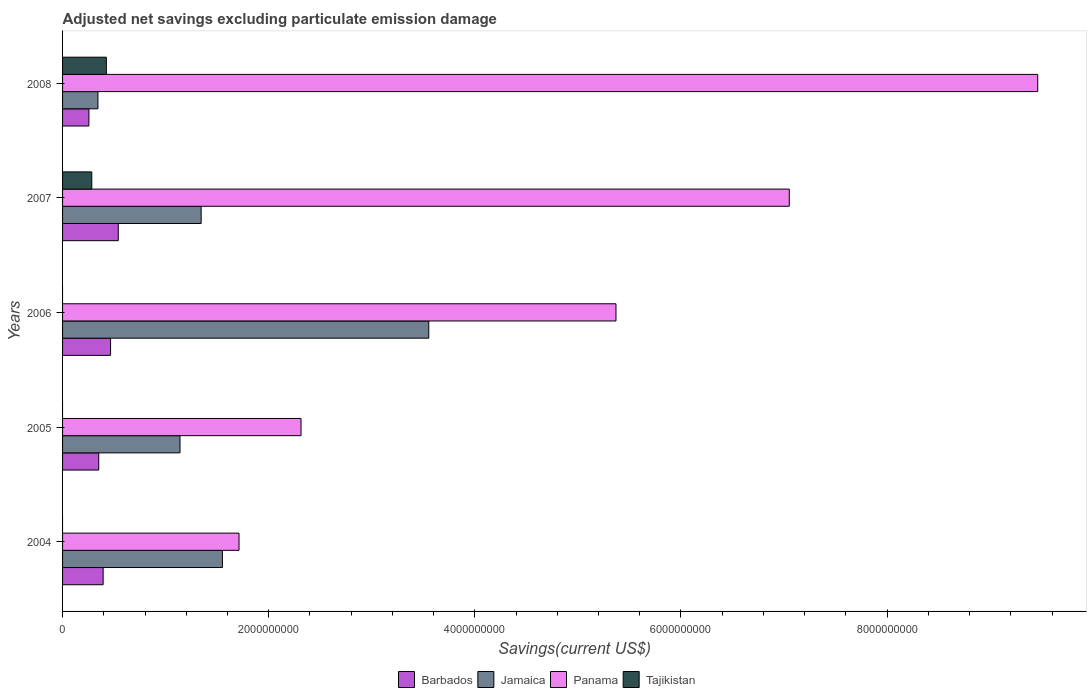Are the number of bars on each tick of the Y-axis equal?
Make the answer very short. No. How many bars are there on the 2nd tick from the top?
Offer a very short reply. 4. How many bars are there on the 4th tick from the bottom?
Ensure brevity in your answer.  4. What is the label of the 2nd group of bars from the top?
Keep it short and to the point. 2007. In how many cases, is the number of bars for a given year not equal to the number of legend labels?
Your answer should be compact. 3. What is the adjusted net savings in Barbados in 2008?
Ensure brevity in your answer.  2.56e+08. Across all years, what is the maximum adjusted net savings in Tajikistan?
Provide a short and direct response. 4.25e+08. Across all years, what is the minimum adjusted net savings in Barbados?
Provide a short and direct response. 2.56e+08. In which year was the adjusted net savings in Panama maximum?
Offer a very short reply. 2008. What is the total adjusted net savings in Panama in the graph?
Keep it short and to the point. 2.59e+1. What is the difference between the adjusted net savings in Jamaica in 2004 and that in 2007?
Your answer should be compact. 2.06e+08. What is the difference between the adjusted net savings in Panama in 2006 and the adjusted net savings in Barbados in 2005?
Ensure brevity in your answer.  5.02e+09. What is the average adjusted net savings in Tajikistan per year?
Offer a very short reply. 1.42e+08. In the year 2008, what is the difference between the adjusted net savings in Tajikistan and adjusted net savings in Barbados?
Provide a short and direct response. 1.69e+08. What is the ratio of the adjusted net savings in Panama in 2004 to that in 2008?
Offer a terse response. 0.18. Is the adjusted net savings in Panama in 2004 less than that in 2005?
Give a very brief answer. Yes. What is the difference between the highest and the second highest adjusted net savings in Panama?
Provide a short and direct response. 2.41e+09. What is the difference between the highest and the lowest adjusted net savings in Barbados?
Give a very brief answer. 2.85e+08. Is the sum of the adjusted net savings in Jamaica in 2006 and 2007 greater than the maximum adjusted net savings in Panama across all years?
Your answer should be compact. No. What is the difference between two consecutive major ticks on the X-axis?
Your answer should be compact. 2.00e+09. Does the graph contain any zero values?
Provide a short and direct response. Yes. How are the legend labels stacked?
Ensure brevity in your answer.  Horizontal. What is the title of the graph?
Your answer should be very brief. Adjusted net savings excluding particulate emission damage. What is the label or title of the X-axis?
Your answer should be very brief. Savings(current US$). What is the Savings(current US$) of Barbados in 2004?
Your answer should be very brief. 3.94e+08. What is the Savings(current US$) of Jamaica in 2004?
Make the answer very short. 1.55e+09. What is the Savings(current US$) of Panama in 2004?
Ensure brevity in your answer.  1.71e+09. What is the Savings(current US$) in Tajikistan in 2004?
Keep it short and to the point. 0. What is the Savings(current US$) in Barbados in 2005?
Your answer should be very brief. 3.51e+08. What is the Savings(current US$) of Jamaica in 2005?
Keep it short and to the point. 1.14e+09. What is the Savings(current US$) of Panama in 2005?
Provide a short and direct response. 2.31e+09. What is the Savings(current US$) of Barbados in 2006?
Offer a terse response. 4.66e+08. What is the Savings(current US$) in Jamaica in 2006?
Provide a short and direct response. 3.55e+09. What is the Savings(current US$) in Panama in 2006?
Provide a succinct answer. 5.37e+09. What is the Savings(current US$) of Tajikistan in 2006?
Your response must be concise. 0. What is the Savings(current US$) in Barbados in 2007?
Offer a very short reply. 5.40e+08. What is the Savings(current US$) of Jamaica in 2007?
Offer a very short reply. 1.34e+09. What is the Savings(current US$) in Panama in 2007?
Offer a very short reply. 7.05e+09. What is the Savings(current US$) of Tajikistan in 2007?
Your answer should be compact. 2.83e+08. What is the Savings(current US$) in Barbados in 2008?
Provide a short and direct response. 2.56e+08. What is the Savings(current US$) in Jamaica in 2008?
Give a very brief answer. 3.43e+08. What is the Savings(current US$) of Panama in 2008?
Offer a terse response. 9.46e+09. What is the Savings(current US$) in Tajikistan in 2008?
Offer a terse response. 4.25e+08. Across all years, what is the maximum Savings(current US$) in Barbados?
Your response must be concise. 5.40e+08. Across all years, what is the maximum Savings(current US$) of Jamaica?
Ensure brevity in your answer.  3.55e+09. Across all years, what is the maximum Savings(current US$) in Panama?
Ensure brevity in your answer.  9.46e+09. Across all years, what is the maximum Savings(current US$) in Tajikistan?
Provide a succinct answer. 4.25e+08. Across all years, what is the minimum Savings(current US$) of Barbados?
Offer a terse response. 2.56e+08. Across all years, what is the minimum Savings(current US$) in Jamaica?
Offer a terse response. 3.43e+08. Across all years, what is the minimum Savings(current US$) of Panama?
Your response must be concise. 1.71e+09. What is the total Savings(current US$) of Barbados in the graph?
Keep it short and to the point. 2.01e+09. What is the total Savings(current US$) of Jamaica in the graph?
Your response must be concise. 7.93e+09. What is the total Savings(current US$) of Panama in the graph?
Your answer should be compact. 2.59e+1. What is the total Savings(current US$) of Tajikistan in the graph?
Offer a terse response. 7.08e+08. What is the difference between the Savings(current US$) in Barbados in 2004 and that in 2005?
Provide a short and direct response. 4.27e+07. What is the difference between the Savings(current US$) in Jamaica in 2004 and that in 2005?
Keep it short and to the point. 4.11e+08. What is the difference between the Savings(current US$) in Panama in 2004 and that in 2005?
Offer a terse response. -6.02e+08. What is the difference between the Savings(current US$) of Barbados in 2004 and that in 2006?
Ensure brevity in your answer.  -7.21e+07. What is the difference between the Savings(current US$) in Jamaica in 2004 and that in 2006?
Ensure brevity in your answer.  -2.00e+09. What is the difference between the Savings(current US$) of Panama in 2004 and that in 2006?
Provide a succinct answer. -3.66e+09. What is the difference between the Savings(current US$) of Barbados in 2004 and that in 2007?
Keep it short and to the point. -1.47e+08. What is the difference between the Savings(current US$) in Jamaica in 2004 and that in 2007?
Your response must be concise. 2.06e+08. What is the difference between the Savings(current US$) in Panama in 2004 and that in 2007?
Offer a very short reply. -5.34e+09. What is the difference between the Savings(current US$) in Barbados in 2004 and that in 2008?
Your answer should be compact. 1.38e+08. What is the difference between the Savings(current US$) of Jamaica in 2004 and that in 2008?
Offer a very short reply. 1.21e+09. What is the difference between the Savings(current US$) in Panama in 2004 and that in 2008?
Your response must be concise. -7.75e+09. What is the difference between the Savings(current US$) in Barbados in 2005 and that in 2006?
Make the answer very short. -1.15e+08. What is the difference between the Savings(current US$) of Jamaica in 2005 and that in 2006?
Make the answer very short. -2.41e+09. What is the difference between the Savings(current US$) in Panama in 2005 and that in 2006?
Keep it short and to the point. -3.06e+09. What is the difference between the Savings(current US$) of Barbados in 2005 and that in 2007?
Offer a very short reply. -1.89e+08. What is the difference between the Savings(current US$) of Jamaica in 2005 and that in 2007?
Offer a terse response. -2.05e+08. What is the difference between the Savings(current US$) in Panama in 2005 and that in 2007?
Your response must be concise. -4.74e+09. What is the difference between the Savings(current US$) of Barbados in 2005 and that in 2008?
Ensure brevity in your answer.  9.55e+07. What is the difference between the Savings(current US$) of Jamaica in 2005 and that in 2008?
Provide a succinct answer. 7.96e+08. What is the difference between the Savings(current US$) in Panama in 2005 and that in 2008?
Your answer should be very brief. -7.15e+09. What is the difference between the Savings(current US$) in Barbados in 2006 and that in 2007?
Your answer should be compact. -7.46e+07. What is the difference between the Savings(current US$) in Jamaica in 2006 and that in 2007?
Make the answer very short. 2.21e+09. What is the difference between the Savings(current US$) of Panama in 2006 and that in 2007?
Make the answer very short. -1.68e+09. What is the difference between the Savings(current US$) in Barbados in 2006 and that in 2008?
Make the answer very short. 2.10e+08. What is the difference between the Savings(current US$) in Jamaica in 2006 and that in 2008?
Provide a succinct answer. 3.21e+09. What is the difference between the Savings(current US$) in Panama in 2006 and that in 2008?
Provide a succinct answer. -4.09e+09. What is the difference between the Savings(current US$) in Barbados in 2007 and that in 2008?
Your answer should be very brief. 2.85e+08. What is the difference between the Savings(current US$) in Jamaica in 2007 and that in 2008?
Provide a short and direct response. 1.00e+09. What is the difference between the Savings(current US$) of Panama in 2007 and that in 2008?
Keep it short and to the point. -2.41e+09. What is the difference between the Savings(current US$) in Tajikistan in 2007 and that in 2008?
Your answer should be very brief. -1.42e+08. What is the difference between the Savings(current US$) of Barbados in 2004 and the Savings(current US$) of Jamaica in 2005?
Offer a very short reply. -7.46e+08. What is the difference between the Savings(current US$) in Barbados in 2004 and the Savings(current US$) in Panama in 2005?
Offer a very short reply. -1.92e+09. What is the difference between the Savings(current US$) of Jamaica in 2004 and the Savings(current US$) of Panama in 2005?
Offer a terse response. -7.63e+08. What is the difference between the Savings(current US$) of Barbados in 2004 and the Savings(current US$) of Jamaica in 2006?
Provide a short and direct response. -3.16e+09. What is the difference between the Savings(current US$) of Barbados in 2004 and the Savings(current US$) of Panama in 2006?
Your response must be concise. -4.98e+09. What is the difference between the Savings(current US$) of Jamaica in 2004 and the Savings(current US$) of Panama in 2006?
Offer a terse response. -3.82e+09. What is the difference between the Savings(current US$) of Barbados in 2004 and the Savings(current US$) of Jamaica in 2007?
Ensure brevity in your answer.  -9.51e+08. What is the difference between the Savings(current US$) in Barbados in 2004 and the Savings(current US$) in Panama in 2007?
Provide a short and direct response. -6.66e+09. What is the difference between the Savings(current US$) in Barbados in 2004 and the Savings(current US$) in Tajikistan in 2007?
Offer a terse response. 1.10e+08. What is the difference between the Savings(current US$) in Jamaica in 2004 and the Savings(current US$) in Panama in 2007?
Offer a very short reply. -5.50e+09. What is the difference between the Savings(current US$) in Jamaica in 2004 and the Savings(current US$) in Tajikistan in 2007?
Your answer should be compact. 1.27e+09. What is the difference between the Savings(current US$) in Panama in 2004 and the Savings(current US$) in Tajikistan in 2007?
Offer a very short reply. 1.43e+09. What is the difference between the Savings(current US$) in Barbados in 2004 and the Savings(current US$) in Jamaica in 2008?
Ensure brevity in your answer.  5.04e+07. What is the difference between the Savings(current US$) in Barbados in 2004 and the Savings(current US$) in Panama in 2008?
Provide a short and direct response. -9.07e+09. What is the difference between the Savings(current US$) in Barbados in 2004 and the Savings(current US$) in Tajikistan in 2008?
Your answer should be compact. -3.12e+07. What is the difference between the Savings(current US$) in Jamaica in 2004 and the Savings(current US$) in Panama in 2008?
Give a very brief answer. -7.91e+09. What is the difference between the Savings(current US$) in Jamaica in 2004 and the Savings(current US$) in Tajikistan in 2008?
Provide a short and direct response. 1.13e+09. What is the difference between the Savings(current US$) of Panama in 2004 and the Savings(current US$) of Tajikistan in 2008?
Give a very brief answer. 1.29e+09. What is the difference between the Savings(current US$) in Barbados in 2005 and the Savings(current US$) in Jamaica in 2006?
Offer a very short reply. -3.20e+09. What is the difference between the Savings(current US$) in Barbados in 2005 and the Savings(current US$) in Panama in 2006?
Provide a succinct answer. -5.02e+09. What is the difference between the Savings(current US$) in Jamaica in 2005 and the Savings(current US$) in Panama in 2006?
Your response must be concise. -4.23e+09. What is the difference between the Savings(current US$) in Barbados in 2005 and the Savings(current US$) in Jamaica in 2007?
Offer a terse response. -9.94e+08. What is the difference between the Savings(current US$) of Barbados in 2005 and the Savings(current US$) of Panama in 2007?
Ensure brevity in your answer.  -6.70e+09. What is the difference between the Savings(current US$) of Barbados in 2005 and the Savings(current US$) of Tajikistan in 2007?
Ensure brevity in your answer.  6.76e+07. What is the difference between the Savings(current US$) of Jamaica in 2005 and the Savings(current US$) of Panama in 2007?
Offer a very short reply. -5.91e+09. What is the difference between the Savings(current US$) of Jamaica in 2005 and the Savings(current US$) of Tajikistan in 2007?
Give a very brief answer. 8.56e+08. What is the difference between the Savings(current US$) in Panama in 2005 and the Savings(current US$) in Tajikistan in 2007?
Make the answer very short. 2.03e+09. What is the difference between the Savings(current US$) in Barbados in 2005 and the Savings(current US$) in Jamaica in 2008?
Ensure brevity in your answer.  7.74e+06. What is the difference between the Savings(current US$) in Barbados in 2005 and the Savings(current US$) in Panama in 2008?
Your answer should be very brief. -9.11e+09. What is the difference between the Savings(current US$) of Barbados in 2005 and the Savings(current US$) of Tajikistan in 2008?
Give a very brief answer. -7.39e+07. What is the difference between the Savings(current US$) of Jamaica in 2005 and the Savings(current US$) of Panama in 2008?
Offer a terse response. -8.32e+09. What is the difference between the Savings(current US$) in Jamaica in 2005 and the Savings(current US$) in Tajikistan in 2008?
Your answer should be compact. 7.15e+08. What is the difference between the Savings(current US$) in Panama in 2005 and the Savings(current US$) in Tajikistan in 2008?
Offer a terse response. 1.89e+09. What is the difference between the Savings(current US$) in Barbados in 2006 and the Savings(current US$) in Jamaica in 2007?
Give a very brief answer. -8.79e+08. What is the difference between the Savings(current US$) in Barbados in 2006 and the Savings(current US$) in Panama in 2007?
Your answer should be very brief. -6.58e+09. What is the difference between the Savings(current US$) in Barbados in 2006 and the Savings(current US$) in Tajikistan in 2007?
Give a very brief answer. 1.82e+08. What is the difference between the Savings(current US$) in Jamaica in 2006 and the Savings(current US$) in Panama in 2007?
Offer a very short reply. -3.50e+09. What is the difference between the Savings(current US$) in Jamaica in 2006 and the Savings(current US$) in Tajikistan in 2007?
Offer a very short reply. 3.27e+09. What is the difference between the Savings(current US$) in Panama in 2006 and the Savings(current US$) in Tajikistan in 2007?
Provide a short and direct response. 5.09e+09. What is the difference between the Savings(current US$) of Barbados in 2006 and the Savings(current US$) of Jamaica in 2008?
Keep it short and to the point. 1.23e+08. What is the difference between the Savings(current US$) in Barbados in 2006 and the Savings(current US$) in Panama in 2008?
Your answer should be very brief. -9.00e+09. What is the difference between the Savings(current US$) in Barbados in 2006 and the Savings(current US$) in Tajikistan in 2008?
Offer a very short reply. 4.08e+07. What is the difference between the Savings(current US$) in Jamaica in 2006 and the Savings(current US$) in Panama in 2008?
Your response must be concise. -5.91e+09. What is the difference between the Savings(current US$) of Jamaica in 2006 and the Savings(current US$) of Tajikistan in 2008?
Keep it short and to the point. 3.13e+09. What is the difference between the Savings(current US$) in Panama in 2006 and the Savings(current US$) in Tajikistan in 2008?
Your answer should be very brief. 4.94e+09. What is the difference between the Savings(current US$) of Barbados in 2007 and the Savings(current US$) of Jamaica in 2008?
Provide a succinct answer. 1.97e+08. What is the difference between the Savings(current US$) of Barbados in 2007 and the Savings(current US$) of Panama in 2008?
Provide a succinct answer. -8.92e+09. What is the difference between the Savings(current US$) in Barbados in 2007 and the Savings(current US$) in Tajikistan in 2008?
Your answer should be very brief. 1.15e+08. What is the difference between the Savings(current US$) in Jamaica in 2007 and the Savings(current US$) in Panama in 2008?
Give a very brief answer. -8.12e+09. What is the difference between the Savings(current US$) of Jamaica in 2007 and the Savings(current US$) of Tajikistan in 2008?
Offer a very short reply. 9.20e+08. What is the difference between the Savings(current US$) in Panama in 2007 and the Savings(current US$) in Tajikistan in 2008?
Make the answer very short. 6.63e+09. What is the average Savings(current US$) in Barbados per year?
Provide a short and direct response. 4.01e+08. What is the average Savings(current US$) in Jamaica per year?
Your response must be concise. 1.59e+09. What is the average Savings(current US$) in Panama per year?
Offer a very short reply. 5.18e+09. What is the average Savings(current US$) of Tajikistan per year?
Your answer should be compact. 1.42e+08. In the year 2004, what is the difference between the Savings(current US$) of Barbados and Savings(current US$) of Jamaica?
Your answer should be very brief. -1.16e+09. In the year 2004, what is the difference between the Savings(current US$) of Barbados and Savings(current US$) of Panama?
Provide a short and direct response. -1.32e+09. In the year 2004, what is the difference between the Savings(current US$) in Jamaica and Savings(current US$) in Panama?
Provide a short and direct response. -1.61e+08. In the year 2005, what is the difference between the Savings(current US$) in Barbados and Savings(current US$) in Jamaica?
Your response must be concise. -7.89e+08. In the year 2005, what is the difference between the Savings(current US$) in Barbados and Savings(current US$) in Panama?
Give a very brief answer. -1.96e+09. In the year 2005, what is the difference between the Savings(current US$) in Jamaica and Savings(current US$) in Panama?
Provide a short and direct response. -1.17e+09. In the year 2006, what is the difference between the Savings(current US$) in Barbados and Savings(current US$) in Jamaica?
Keep it short and to the point. -3.09e+09. In the year 2006, what is the difference between the Savings(current US$) of Barbados and Savings(current US$) of Panama?
Give a very brief answer. -4.90e+09. In the year 2006, what is the difference between the Savings(current US$) in Jamaica and Savings(current US$) in Panama?
Give a very brief answer. -1.82e+09. In the year 2007, what is the difference between the Savings(current US$) in Barbados and Savings(current US$) in Jamaica?
Provide a short and direct response. -8.04e+08. In the year 2007, what is the difference between the Savings(current US$) in Barbados and Savings(current US$) in Panama?
Provide a succinct answer. -6.51e+09. In the year 2007, what is the difference between the Savings(current US$) in Barbados and Savings(current US$) in Tajikistan?
Offer a terse response. 2.57e+08. In the year 2007, what is the difference between the Savings(current US$) in Jamaica and Savings(current US$) in Panama?
Your answer should be compact. -5.71e+09. In the year 2007, what is the difference between the Savings(current US$) of Jamaica and Savings(current US$) of Tajikistan?
Offer a very short reply. 1.06e+09. In the year 2007, what is the difference between the Savings(current US$) of Panama and Savings(current US$) of Tajikistan?
Offer a very short reply. 6.77e+09. In the year 2008, what is the difference between the Savings(current US$) in Barbados and Savings(current US$) in Jamaica?
Your answer should be very brief. -8.77e+07. In the year 2008, what is the difference between the Savings(current US$) in Barbados and Savings(current US$) in Panama?
Your response must be concise. -9.21e+09. In the year 2008, what is the difference between the Savings(current US$) in Barbados and Savings(current US$) in Tajikistan?
Your response must be concise. -1.69e+08. In the year 2008, what is the difference between the Savings(current US$) of Jamaica and Savings(current US$) of Panama?
Give a very brief answer. -9.12e+09. In the year 2008, what is the difference between the Savings(current US$) of Jamaica and Savings(current US$) of Tajikistan?
Your answer should be compact. -8.17e+07. In the year 2008, what is the difference between the Savings(current US$) of Panama and Savings(current US$) of Tajikistan?
Provide a short and direct response. 9.04e+09. What is the ratio of the Savings(current US$) of Barbados in 2004 to that in 2005?
Ensure brevity in your answer.  1.12. What is the ratio of the Savings(current US$) in Jamaica in 2004 to that in 2005?
Your answer should be very brief. 1.36. What is the ratio of the Savings(current US$) of Panama in 2004 to that in 2005?
Keep it short and to the point. 0.74. What is the ratio of the Savings(current US$) in Barbados in 2004 to that in 2006?
Give a very brief answer. 0.85. What is the ratio of the Savings(current US$) of Jamaica in 2004 to that in 2006?
Offer a terse response. 0.44. What is the ratio of the Savings(current US$) of Panama in 2004 to that in 2006?
Keep it short and to the point. 0.32. What is the ratio of the Savings(current US$) of Barbados in 2004 to that in 2007?
Ensure brevity in your answer.  0.73. What is the ratio of the Savings(current US$) of Jamaica in 2004 to that in 2007?
Give a very brief answer. 1.15. What is the ratio of the Savings(current US$) of Panama in 2004 to that in 2007?
Ensure brevity in your answer.  0.24. What is the ratio of the Savings(current US$) in Barbados in 2004 to that in 2008?
Ensure brevity in your answer.  1.54. What is the ratio of the Savings(current US$) of Jamaica in 2004 to that in 2008?
Provide a short and direct response. 4.52. What is the ratio of the Savings(current US$) in Panama in 2004 to that in 2008?
Offer a terse response. 0.18. What is the ratio of the Savings(current US$) of Barbados in 2005 to that in 2006?
Give a very brief answer. 0.75. What is the ratio of the Savings(current US$) in Jamaica in 2005 to that in 2006?
Keep it short and to the point. 0.32. What is the ratio of the Savings(current US$) of Panama in 2005 to that in 2006?
Keep it short and to the point. 0.43. What is the ratio of the Savings(current US$) in Barbados in 2005 to that in 2007?
Provide a short and direct response. 0.65. What is the ratio of the Savings(current US$) of Jamaica in 2005 to that in 2007?
Your answer should be compact. 0.85. What is the ratio of the Savings(current US$) in Panama in 2005 to that in 2007?
Provide a short and direct response. 0.33. What is the ratio of the Savings(current US$) in Barbados in 2005 to that in 2008?
Offer a very short reply. 1.37. What is the ratio of the Savings(current US$) in Jamaica in 2005 to that in 2008?
Offer a terse response. 3.32. What is the ratio of the Savings(current US$) in Panama in 2005 to that in 2008?
Provide a short and direct response. 0.24. What is the ratio of the Savings(current US$) in Barbados in 2006 to that in 2007?
Provide a succinct answer. 0.86. What is the ratio of the Savings(current US$) of Jamaica in 2006 to that in 2007?
Offer a very short reply. 2.64. What is the ratio of the Savings(current US$) in Panama in 2006 to that in 2007?
Offer a terse response. 0.76. What is the ratio of the Savings(current US$) of Barbados in 2006 to that in 2008?
Provide a succinct answer. 1.82. What is the ratio of the Savings(current US$) in Jamaica in 2006 to that in 2008?
Make the answer very short. 10.35. What is the ratio of the Savings(current US$) in Panama in 2006 to that in 2008?
Make the answer very short. 0.57. What is the ratio of the Savings(current US$) in Barbados in 2007 to that in 2008?
Your answer should be very brief. 2.11. What is the ratio of the Savings(current US$) of Jamaica in 2007 to that in 2008?
Your response must be concise. 3.92. What is the ratio of the Savings(current US$) in Panama in 2007 to that in 2008?
Offer a terse response. 0.75. What is the ratio of the Savings(current US$) in Tajikistan in 2007 to that in 2008?
Provide a short and direct response. 0.67. What is the difference between the highest and the second highest Savings(current US$) of Barbados?
Your answer should be compact. 7.46e+07. What is the difference between the highest and the second highest Savings(current US$) in Jamaica?
Make the answer very short. 2.00e+09. What is the difference between the highest and the second highest Savings(current US$) of Panama?
Your answer should be compact. 2.41e+09. What is the difference between the highest and the lowest Savings(current US$) in Barbados?
Offer a terse response. 2.85e+08. What is the difference between the highest and the lowest Savings(current US$) of Jamaica?
Give a very brief answer. 3.21e+09. What is the difference between the highest and the lowest Savings(current US$) of Panama?
Provide a succinct answer. 7.75e+09. What is the difference between the highest and the lowest Savings(current US$) of Tajikistan?
Offer a terse response. 4.25e+08. 